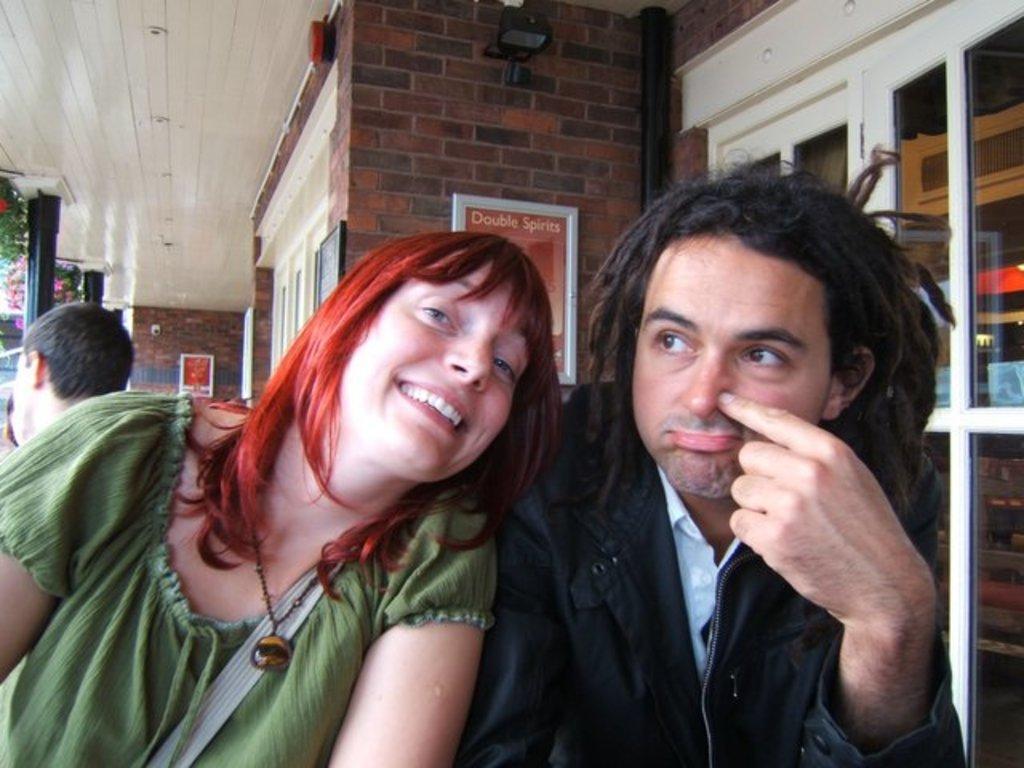How would you summarize this image in a sentence or two? In this image we can see two persons. On the left side of the image we can see a lady where has she is smiling and she wore a green color dress. On the right side of the image we can see a person keeping different facial expression. 